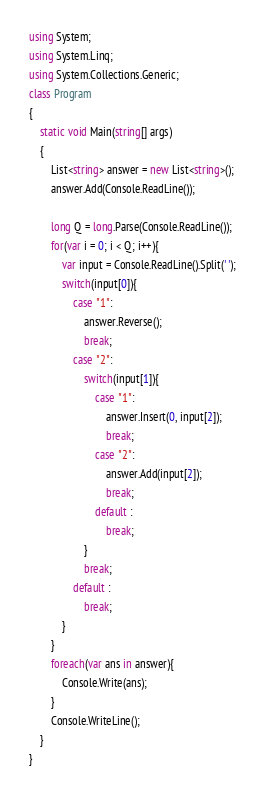<code> <loc_0><loc_0><loc_500><loc_500><_C#_>using System;
using System.Linq;
using System.Collections.Generic;
class Program
{
	static void Main(string[] args)
	{
		List<string> answer = new List<string>();
		answer.Add(Console.ReadLine());
		
		long Q = long.Parse(Console.ReadLine());
		for(var i = 0; i < Q; i++){
		    var input = Console.ReadLine().Split(' ');
		    switch(input[0]){
		        case "1":
		            answer.Reverse();
		            break;
		        case "2":
		            switch(input[1]){
		                case "1":
		                    answer.Insert(0, input[2]);
		                    break;
		                case "2":
		                    answer.Add(input[2]);
		                    break;
		                default :
		                    break;
		            }
		            break;
		        default :
		            break;
		    }
		}
		foreach(var ans in answer){
		    Console.Write(ans);
		}
		Console.WriteLine();
	}
}</code> 